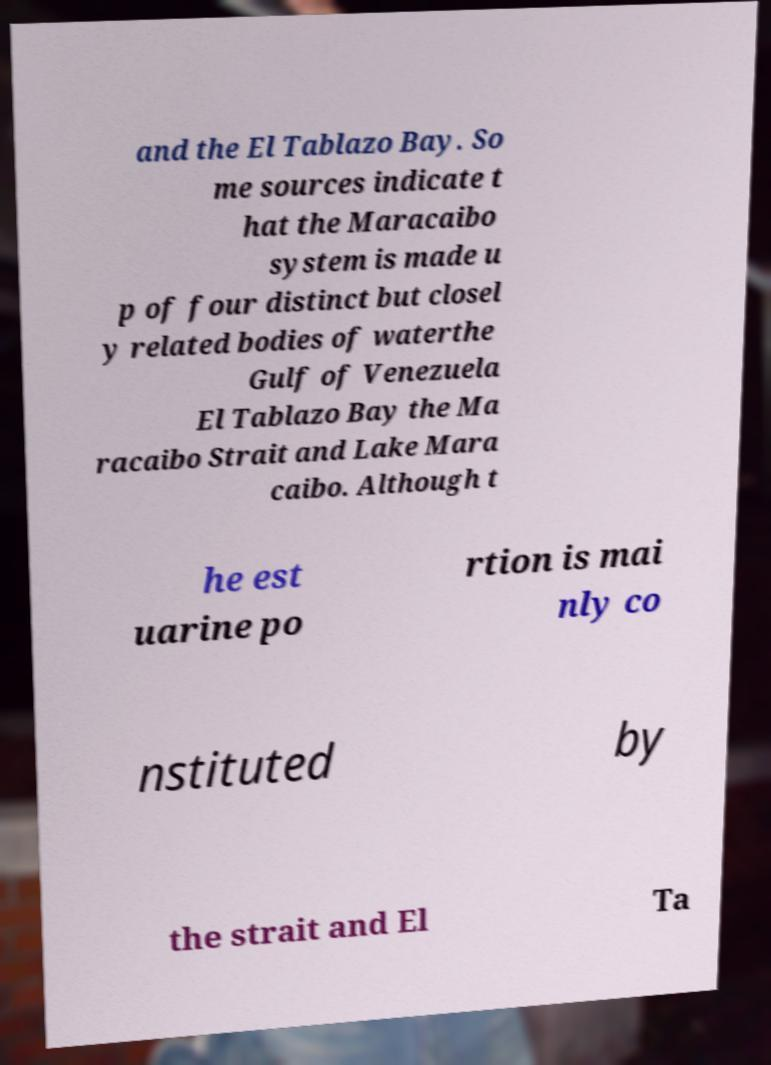There's text embedded in this image that I need extracted. Can you transcribe it verbatim? and the El Tablazo Bay. So me sources indicate t hat the Maracaibo system is made u p of four distinct but closel y related bodies of waterthe Gulf of Venezuela El Tablazo Bay the Ma racaibo Strait and Lake Mara caibo. Although t he est uarine po rtion is mai nly co nstituted by the strait and El Ta 